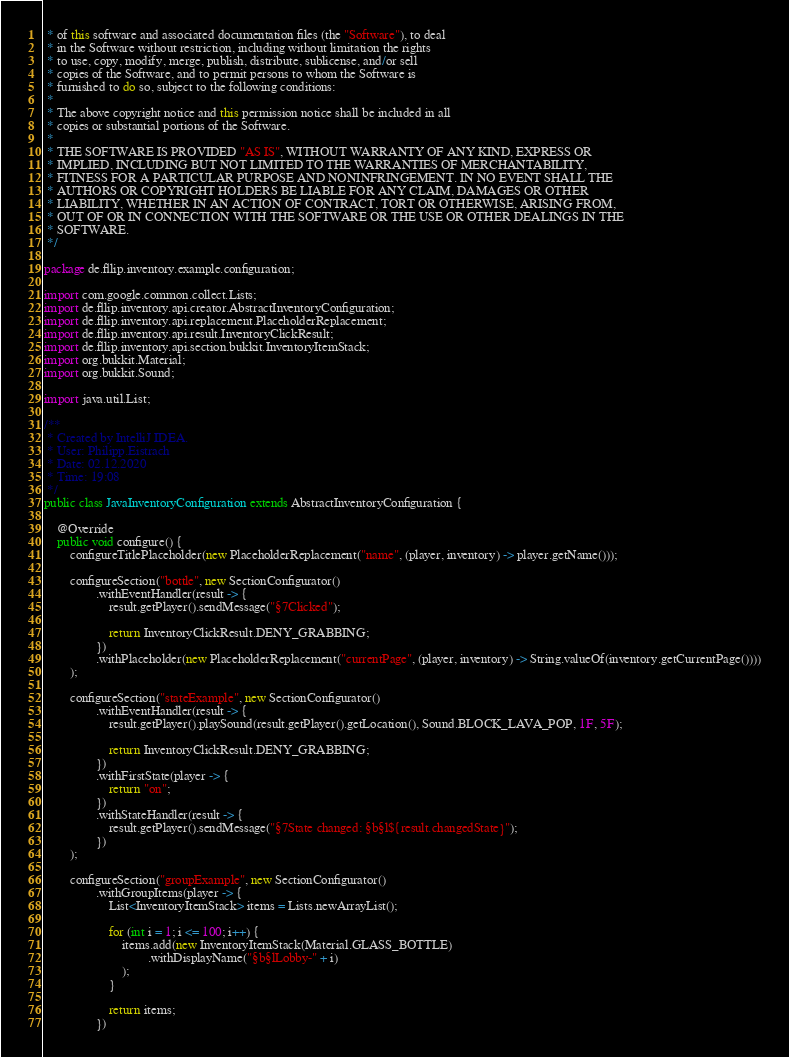<code> <loc_0><loc_0><loc_500><loc_500><_Java_> * of this software and associated documentation files (the "Software"), to deal
 * in the Software without restriction, including without limitation the rights
 * to use, copy, modify, merge, publish, distribute, sublicense, and/or sell
 * copies of the Software, and to permit persons to whom the Software is
 * furnished to do so, subject to the following conditions:
 *
 * The above copyright notice and this permission notice shall be included in all
 * copies or substantial portions of the Software.
 *
 * THE SOFTWARE IS PROVIDED "AS IS", WITHOUT WARRANTY OF ANY KIND, EXPRESS OR
 * IMPLIED, INCLUDING BUT NOT LIMITED TO THE WARRANTIES OF MERCHANTABILITY,
 * FITNESS FOR A PARTICULAR PURPOSE AND NONINFRINGEMENT. IN NO EVENT SHALL THE
 * AUTHORS OR COPYRIGHT HOLDERS BE LIABLE FOR ANY CLAIM, DAMAGES OR OTHER
 * LIABILITY, WHETHER IN AN ACTION OF CONTRACT, TORT OR OTHERWISE, ARISING FROM,
 * OUT OF OR IN CONNECTION WITH THE SOFTWARE OR THE USE OR OTHER DEALINGS IN THE
 * SOFTWARE.
 */

package de.fllip.inventory.example.configuration;

import com.google.common.collect.Lists;
import de.fllip.inventory.api.creator.AbstractInventoryConfiguration;
import de.fllip.inventory.api.replacement.PlaceholderReplacement;
import de.fllip.inventory.api.result.InventoryClickResult;
import de.fllip.inventory.api.section.bukkit.InventoryItemStack;
import org.bukkit.Material;
import org.bukkit.Sound;

import java.util.List;

/**
 * Created by IntelliJ IDEA.
 * User: Philipp.Eistrach
 * Date: 02.12.2020
 * Time: 19:08
 */
public class JavaInventoryConfiguration extends AbstractInventoryConfiguration {

    @Override
    public void configure() {
        configureTitlePlaceholder(new PlaceholderReplacement("name", (player, inventory) -> player.getName()));

        configureSection("bottle", new SectionConfigurator()
                .withEventHandler(result -> {
                    result.getPlayer().sendMessage("§7Clicked");

                    return InventoryClickResult.DENY_GRABBING;
                })
                .withPlaceholder(new PlaceholderReplacement("currentPage", (player, inventory) -> String.valueOf(inventory.getCurrentPage())))
        );

        configureSection("stateExample", new SectionConfigurator()
                .withEventHandler(result -> {
                    result.getPlayer().playSound(result.getPlayer().getLocation(), Sound.BLOCK_LAVA_POP, 1F, 5F);

                    return InventoryClickResult.DENY_GRABBING;
                })
                .withFirstState(player -> {
                    return "on";
                })
                .withStateHandler(result -> {
                    result.getPlayer().sendMessage("§7State changed: §b§l${result.changedState}");
                })
        );

        configureSection("groupExample", new SectionConfigurator()
                .withGroupItems(player -> {
                    List<InventoryItemStack> items = Lists.newArrayList();

                    for (int i = 1; i <= 100; i++) {
                        items.add(new InventoryItemStack(Material.GLASS_BOTTLE)
                                .withDisplayName("§b§lLobby-" + i)
                        );
                    }

                    return items;
                })</code> 